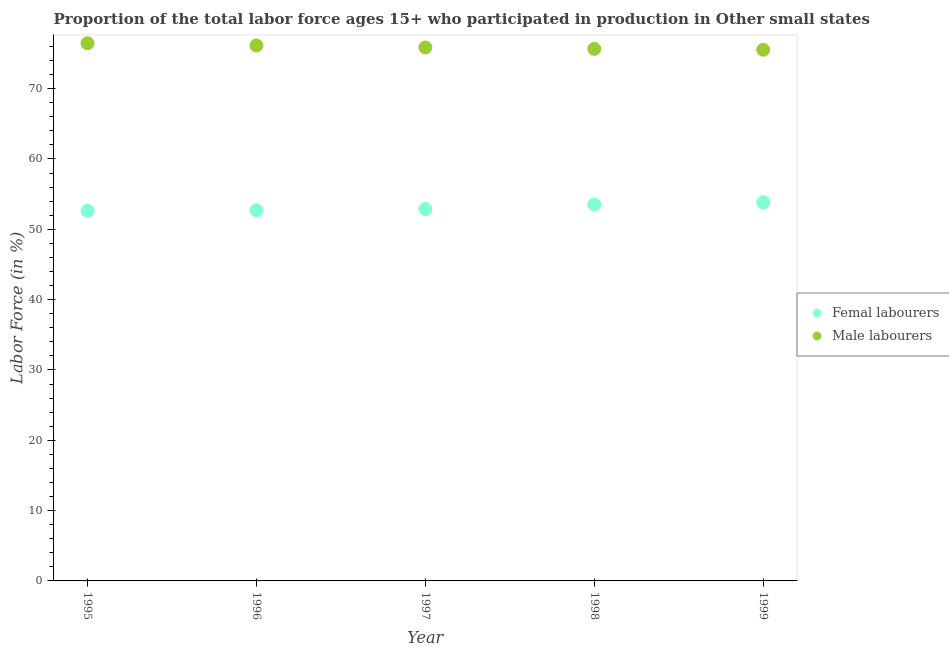What is the percentage of male labour force in 1996?
Provide a succinct answer. 76.14. Across all years, what is the maximum percentage of male labour force?
Give a very brief answer. 76.46. Across all years, what is the minimum percentage of female labor force?
Provide a short and direct response. 52.64. In which year was the percentage of male labour force maximum?
Give a very brief answer. 1995. What is the total percentage of male labour force in the graph?
Your response must be concise. 379.65. What is the difference between the percentage of male labour force in 1997 and that in 1998?
Make the answer very short. 0.2. What is the difference between the percentage of female labor force in 1997 and the percentage of male labour force in 1998?
Keep it short and to the point. -22.77. What is the average percentage of female labor force per year?
Make the answer very short. 53.13. In the year 1999, what is the difference between the percentage of female labor force and percentage of male labour force?
Offer a very short reply. -21.68. What is the ratio of the percentage of male labour force in 1995 to that in 1999?
Make the answer very short. 1.01. What is the difference between the highest and the second highest percentage of male labour force?
Ensure brevity in your answer.  0.32. What is the difference between the highest and the lowest percentage of female labor force?
Your response must be concise. 1.21. Does the percentage of male labour force monotonically increase over the years?
Provide a succinct answer. No. Is the percentage of male labour force strictly greater than the percentage of female labor force over the years?
Keep it short and to the point. Yes. Is the percentage of female labor force strictly less than the percentage of male labour force over the years?
Make the answer very short. Yes. Where does the legend appear in the graph?
Offer a very short reply. Center right. How many legend labels are there?
Your answer should be compact. 2. How are the legend labels stacked?
Make the answer very short. Vertical. What is the title of the graph?
Make the answer very short. Proportion of the total labor force ages 15+ who participated in production in Other small states. What is the Labor Force (in %) of Femal labourers in 1995?
Provide a short and direct response. 52.64. What is the Labor Force (in %) of Male labourers in 1995?
Offer a terse response. 76.46. What is the Labor Force (in %) of Femal labourers in 1996?
Offer a terse response. 52.72. What is the Labor Force (in %) in Male labourers in 1996?
Provide a short and direct response. 76.14. What is the Labor Force (in %) in Femal labourers in 1997?
Your response must be concise. 52.89. What is the Labor Force (in %) in Male labourers in 1997?
Give a very brief answer. 75.86. What is the Labor Force (in %) in Femal labourers in 1998?
Your answer should be compact. 53.54. What is the Labor Force (in %) in Male labourers in 1998?
Offer a very short reply. 75.66. What is the Labor Force (in %) of Femal labourers in 1999?
Offer a terse response. 53.85. What is the Labor Force (in %) of Male labourers in 1999?
Provide a short and direct response. 75.54. Across all years, what is the maximum Labor Force (in %) in Femal labourers?
Ensure brevity in your answer.  53.85. Across all years, what is the maximum Labor Force (in %) of Male labourers?
Your answer should be compact. 76.46. Across all years, what is the minimum Labor Force (in %) in Femal labourers?
Offer a terse response. 52.64. Across all years, what is the minimum Labor Force (in %) in Male labourers?
Offer a very short reply. 75.54. What is the total Labor Force (in %) in Femal labourers in the graph?
Offer a very short reply. 265.64. What is the total Labor Force (in %) in Male labourers in the graph?
Provide a short and direct response. 379.65. What is the difference between the Labor Force (in %) of Femal labourers in 1995 and that in 1996?
Offer a terse response. -0.07. What is the difference between the Labor Force (in %) of Male labourers in 1995 and that in 1996?
Offer a very short reply. 0.32. What is the difference between the Labor Force (in %) of Femal labourers in 1995 and that in 1997?
Your answer should be very brief. -0.25. What is the difference between the Labor Force (in %) of Male labourers in 1995 and that in 1997?
Ensure brevity in your answer.  0.6. What is the difference between the Labor Force (in %) in Femal labourers in 1995 and that in 1998?
Provide a succinct answer. -0.9. What is the difference between the Labor Force (in %) of Male labourers in 1995 and that in 1998?
Offer a terse response. 0.8. What is the difference between the Labor Force (in %) of Femal labourers in 1995 and that in 1999?
Your response must be concise. -1.21. What is the difference between the Labor Force (in %) in Male labourers in 1995 and that in 1999?
Make the answer very short. 0.92. What is the difference between the Labor Force (in %) in Femal labourers in 1996 and that in 1997?
Your answer should be very brief. -0.17. What is the difference between the Labor Force (in %) in Male labourers in 1996 and that in 1997?
Provide a succinct answer. 0.28. What is the difference between the Labor Force (in %) in Femal labourers in 1996 and that in 1998?
Give a very brief answer. -0.82. What is the difference between the Labor Force (in %) of Male labourers in 1996 and that in 1998?
Your answer should be very brief. 0.48. What is the difference between the Labor Force (in %) of Femal labourers in 1996 and that in 1999?
Your answer should be compact. -1.14. What is the difference between the Labor Force (in %) of Male labourers in 1996 and that in 1999?
Your answer should be very brief. 0.6. What is the difference between the Labor Force (in %) of Femal labourers in 1997 and that in 1998?
Provide a succinct answer. -0.65. What is the difference between the Labor Force (in %) in Male labourers in 1997 and that in 1998?
Offer a terse response. 0.2. What is the difference between the Labor Force (in %) of Femal labourers in 1997 and that in 1999?
Provide a succinct answer. -0.96. What is the difference between the Labor Force (in %) in Male labourers in 1997 and that in 1999?
Provide a succinct answer. 0.32. What is the difference between the Labor Force (in %) of Femal labourers in 1998 and that in 1999?
Make the answer very short. -0.31. What is the difference between the Labor Force (in %) in Male labourers in 1998 and that in 1999?
Your response must be concise. 0.12. What is the difference between the Labor Force (in %) in Femal labourers in 1995 and the Labor Force (in %) in Male labourers in 1996?
Provide a succinct answer. -23.5. What is the difference between the Labor Force (in %) of Femal labourers in 1995 and the Labor Force (in %) of Male labourers in 1997?
Make the answer very short. -23.22. What is the difference between the Labor Force (in %) of Femal labourers in 1995 and the Labor Force (in %) of Male labourers in 1998?
Keep it short and to the point. -23.02. What is the difference between the Labor Force (in %) in Femal labourers in 1995 and the Labor Force (in %) in Male labourers in 1999?
Give a very brief answer. -22.9. What is the difference between the Labor Force (in %) of Femal labourers in 1996 and the Labor Force (in %) of Male labourers in 1997?
Ensure brevity in your answer.  -23.14. What is the difference between the Labor Force (in %) in Femal labourers in 1996 and the Labor Force (in %) in Male labourers in 1998?
Your response must be concise. -22.94. What is the difference between the Labor Force (in %) in Femal labourers in 1996 and the Labor Force (in %) in Male labourers in 1999?
Keep it short and to the point. -22.82. What is the difference between the Labor Force (in %) in Femal labourers in 1997 and the Labor Force (in %) in Male labourers in 1998?
Ensure brevity in your answer.  -22.77. What is the difference between the Labor Force (in %) of Femal labourers in 1997 and the Labor Force (in %) of Male labourers in 1999?
Offer a terse response. -22.65. What is the difference between the Labor Force (in %) of Femal labourers in 1998 and the Labor Force (in %) of Male labourers in 1999?
Ensure brevity in your answer.  -22. What is the average Labor Force (in %) in Femal labourers per year?
Provide a short and direct response. 53.13. What is the average Labor Force (in %) in Male labourers per year?
Your response must be concise. 75.93. In the year 1995, what is the difference between the Labor Force (in %) in Femal labourers and Labor Force (in %) in Male labourers?
Ensure brevity in your answer.  -23.82. In the year 1996, what is the difference between the Labor Force (in %) of Femal labourers and Labor Force (in %) of Male labourers?
Offer a terse response. -23.43. In the year 1997, what is the difference between the Labor Force (in %) in Femal labourers and Labor Force (in %) in Male labourers?
Your answer should be very brief. -22.97. In the year 1998, what is the difference between the Labor Force (in %) in Femal labourers and Labor Force (in %) in Male labourers?
Offer a terse response. -22.12. In the year 1999, what is the difference between the Labor Force (in %) in Femal labourers and Labor Force (in %) in Male labourers?
Offer a very short reply. -21.68. What is the ratio of the Labor Force (in %) in Femal labourers in 1995 to that in 1996?
Provide a short and direct response. 1. What is the ratio of the Labor Force (in %) in Male labourers in 1995 to that in 1996?
Provide a short and direct response. 1. What is the ratio of the Labor Force (in %) of Male labourers in 1995 to that in 1997?
Make the answer very short. 1.01. What is the ratio of the Labor Force (in %) in Femal labourers in 1995 to that in 1998?
Provide a short and direct response. 0.98. What is the ratio of the Labor Force (in %) of Male labourers in 1995 to that in 1998?
Provide a short and direct response. 1.01. What is the ratio of the Labor Force (in %) in Femal labourers in 1995 to that in 1999?
Your answer should be compact. 0.98. What is the ratio of the Labor Force (in %) of Male labourers in 1995 to that in 1999?
Your answer should be very brief. 1.01. What is the ratio of the Labor Force (in %) of Femal labourers in 1996 to that in 1997?
Provide a succinct answer. 1. What is the ratio of the Labor Force (in %) of Male labourers in 1996 to that in 1997?
Offer a very short reply. 1. What is the ratio of the Labor Force (in %) in Femal labourers in 1996 to that in 1998?
Your response must be concise. 0.98. What is the ratio of the Labor Force (in %) in Male labourers in 1996 to that in 1998?
Provide a succinct answer. 1.01. What is the ratio of the Labor Force (in %) in Femal labourers in 1996 to that in 1999?
Your answer should be compact. 0.98. What is the ratio of the Labor Force (in %) in Male labourers in 1996 to that in 1999?
Ensure brevity in your answer.  1.01. What is the ratio of the Labor Force (in %) of Femal labourers in 1997 to that in 1998?
Give a very brief answer. 0.99. What is the ratio of the Labor Force (in %) in Male labourers in 1997 to that in 1998?
Provide a short and direct response. 1. What is the ratio of the Labor Force (in %) of Femal labourers in 1997 to that in 1999?
Your response must be concise. 0.98. What is the ratio of the Labor Force (in %) of Male labourers in 1997 to that in 1999?
Your response must be concise. 1. What is the ratio of the Labor Force (in %) of Male labourers in 1998 to that in 1999?
Keep it short and to the point. 1. What is the difference between the highest and the second highest Labor Force (in %) in Femal labourers?
Your answer should be very brief. 0.31. What is the difference between the highest and the second highest Labor Force (in %) of Male labourers?
Your answer should be very brief. 0.32. What is the difference between the highest and the lowest Labor Force (in %) in Femal labourers?
Your answer should be very brief. 1.21. What is the difference between the highest and the lowest Labor Force (in %) in Male labourers?
Make the answer very short. 0.92. 